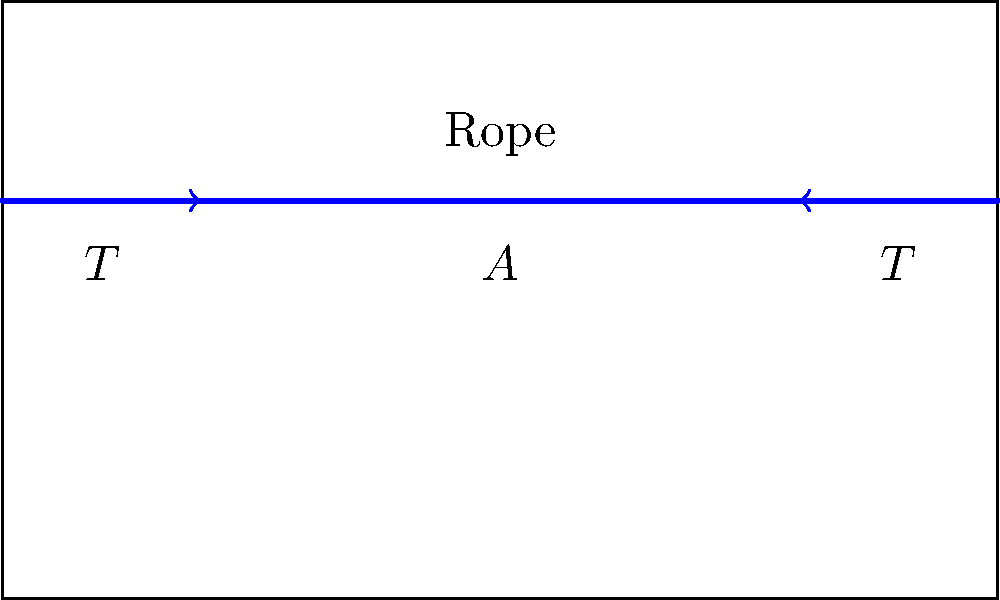As a former tag team partner familiar with wrestling ring setups, you're helping to ensure safety during a special event. The wrestling ring rope has a tension of 2000 N and a circular cross-sectional area of 5 cm². Calculate the stress on the rope in megapascals (MPa). To calculate the stress on the wrestling ring rope, we'll use the following steps:

1) Recall the formula for stress:
   $$ \text{Stress} = \frac{\text{Force}}{\text{Area}} $$

2) We're given:
   - Tension (Force) $T = 2000 \text{ N}$
   - Cross-sectional area $A = 5 \text{ cm}^2$

3) Convert the area to square meters:
   $$ 5 \text{ cm}^2 = 5 \times 10^{-4} \text{ m}^2 $$

4) Apply the stress formula:
   $$ \text{Stress} = \frac{2000 \text{ N}}{5 \times 10^{-4} \text{ m}^2} = 4,000,000 \text{ Pa} $$

5) Convert pascals to megapascals:
   $$ 4,000,000 \text{ Pa} = 4 \text{ MPa} $$

Therefore, the stress on the wrestling ring rope is 4 MPa.
Answer: 4 MPa 